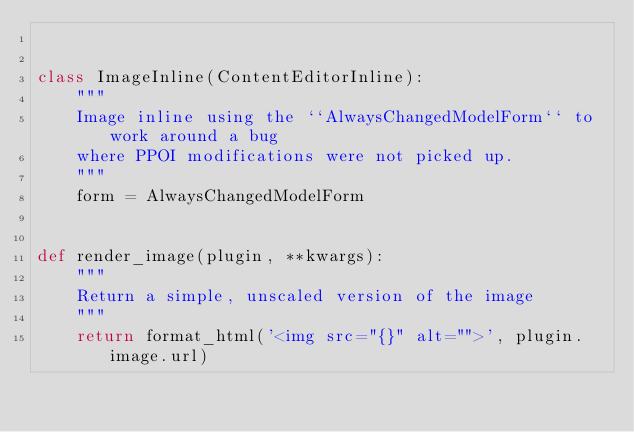Convert code to text. <code><loc_0><loc_0><loc_500><loc_500><_Python_>

class ImageInline(ContentEditorInline):
    """
    Image inline using the ``AlwaysChangedModelForm`` to work around a bug
    where PPOI modifications were not picked up.
    """
    form = AlwaysChangedModelForm


def render_image(plugin, **kwargs):
    """
    Return a simple, unscaled version of the image
    """
    return format_html('<img src="{}" alt="">', plugin.image.url)
</code> 